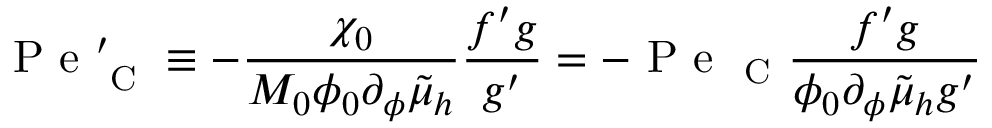<formula> <loc_0><loc_0><loc_500><loc_500>P e _ { C } ^ { \prime } \equiv - \frac { \chi _ { 0 } } { M _ { 0 } \phi _ { 0 } \partial _ { \phi } \tilde { \mu } _ { h } } \frac { f ^ { \prime } g } { g ^ { \prime } } = - P e _ { C } \frac { f ^ { \prime } g } { \phi _ { 0 } \partial _ { \phi } \tilde { \mu } _ { h } g ^ { \prime } }</formula> 